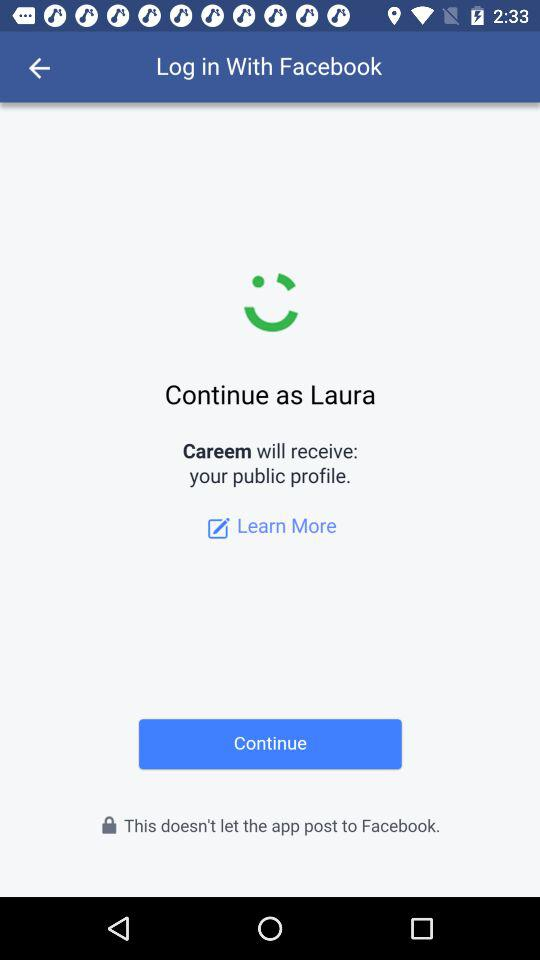What application can I use to log in? The application is "Facebook". 